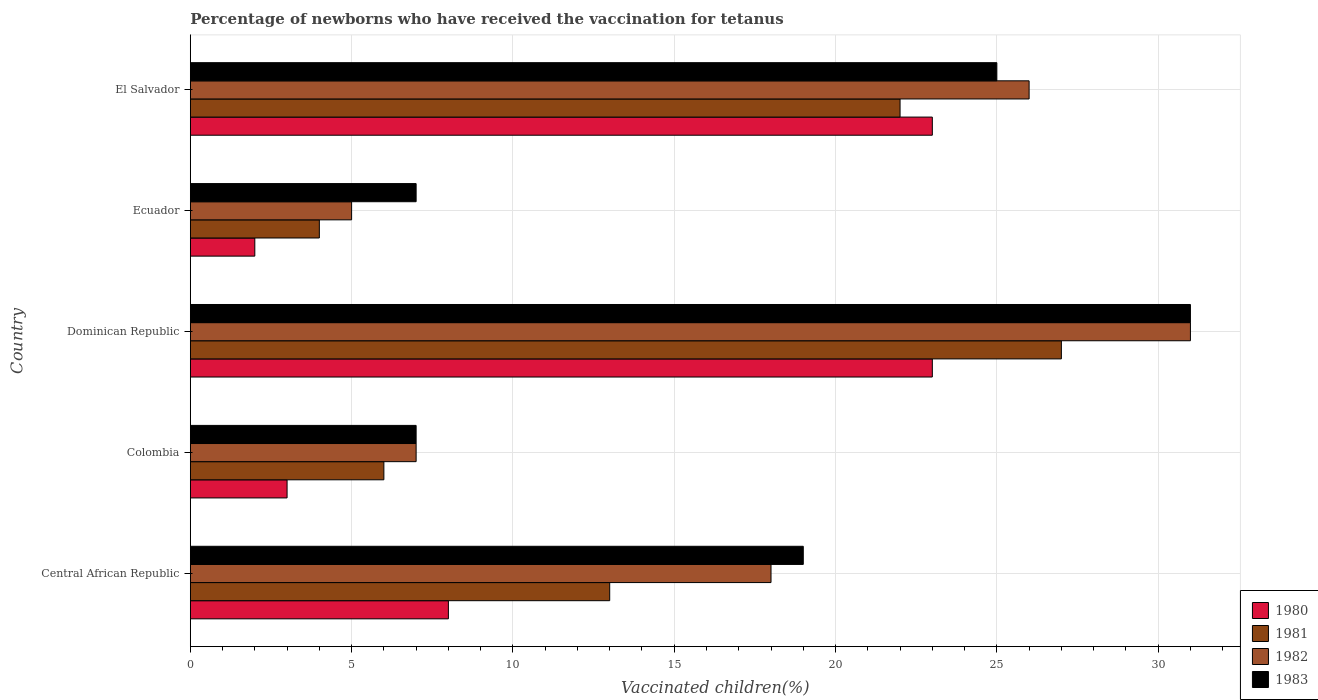How many groups of bars are there?
Ensure brevity in your answer.  5. How many bars are there on the 4th tick from the top?
Keep it short and to the point. 4. How many bars are there on the 1st tick from the bottom?
Ensure brevity in your answer.  4. What is the label of the 2nd group of bars from the top?
Your response must be concise. Ecuador. In which country was the percentage of vaccinated children in 1983 maximum?
Your answer should be very brief. Dominican Republic. In which country was the percentage of vaccinated children in 1980 minimum?
Give a very brief answer. Ecuador. What is the total percentage of vaccinated children in 1983 in the graph?
Your response must be concise. 89. What is the difference between the percentage of vaccinated children in 1982 and percentage of vaccinated children in 1983 in Colombia?
Give a very brief answer. 0. What is the ratio of the percentage of vaccinated children in 1980 in Central African Republic to that in Colombia?
Your answer should be compact. 2.67. Is the percentage of vaccinated children in 1983 in Central African Republic less than that in Colombia?
Offer a very short reply. No. Is the difference between the percentage of vaccinated children in 1982 in Colombia and Ecuador greater than the difference between the percentage of vaccinated children in 1983 in Colombia and Ecuador?
Give a very brief answer. Yes. What is the difference between the highest and the lowest percentage of vaccinated children in 1981?
Keep it short and to the point. 23. In how many countries, is the percentage of vaccinated children in 1982 greater than the average percentage of vaccinated children in 1982 taken over all countries?
Your response must be concise. 3. Is the sum of the percentage of vaccinated children in 1980 in Central African Republic and Colombia greater than the maximum percentage of vaccinated children in 1982 across all countries?
Ensure brevity in your answer.  No. Is it the case that in every country, the sum of the percentage of vaccinated children in 1983 and percentage of vaccinated children in 1982 is greater than the sum of percentage of vaccinated children in 1981 and percentage of vaccinated children in 1980?
Your answer should be compact. No. Is it the case that in every country, the sum of the percentage of vaccinated children in 1983 and percentage of vaccinated children in 1982 is greater than the percentage of vaccinated children in 1980?
Ensure brevity in your answer.  Yes. How many bars are there?
Keep it short and to the point. 20. What is the difference between two consecutive major ticks on the X-axis?
Provide a short and direct response. 5. Does the graph contain any zero values?
Ensure brevity in your answer.  No. What is the title of the graph?
Your answer should be compact. Percentage of newborns who have received the vaccination for tetanus. What is the label or title of the X-axis?
Your answer should be compact. Vaccinated children(%). What is the label or title of the Y-axis?
Your answer should be very brief. Country. What is the Vaccinated children(%) in 1981 in Central African Republic?
Your answer should be compact. 13. What is the Vaccinated children(%) of 1983 in Central African Republic?
Your answer should be compact. 19. What is the Vaccinated children(%) of 1983 in Colombia?
Provide a succinct answer. 7. What is the Vaccinated children(%) in 1980 in Dominican Republic?
Make the answer very short. 23. What is the Vaccinated children(%) in 1981 in Dominican Republic?
Your answer should be very brief. 27. What is the Vaccinated children(%) of 1982 in Dominican Republic?
Give a very brief answer. 31. What is the Vaccinated children(%) of 1983 in Dominican Republic?
Keep it short and to the point. 31. What is the Vaccinated children(%) of 1980 in Ecuador?
Your answer should be very brief. 2. What is the Vaccinated children(%) of 1983 in Ecuador?
Provide a short and direct response. 7. What is the Vaccinated children(%) of 1980 in El Salvador?
Give a very brief answer. 23. What is the Vaccinated children(%) of 1981 in El Salvador?
Offer a very short reply. 22. Across all countries, what is the maximum Vaccinated children(%) of 1980?
Keep it short and to the point. 23. Across all countries, what is the maximum Vaccinated children(%) in 1982?
Your response must be concise. 31. Across all countries, what is the maximum Vaccinated children(%) of 1983?
Give a very brief answer. 31. Across all countries, what is the minimum Vaccinated children(%) of 1980?
Offer a terse response. 2. Across all countries, what is the minimum Vaccinated children(%) of 1981?
Ensure brevity in your answer.  4. Across all countries, what is the minimum Vaccinated children(%) of 1982?
Provide a short and direct response. 5. Across all countries, what is the minimum Vaccinated children(%) in 1983?
Your answer should be very brief. 7. What is the total Vaccinated children(%) of 1983 in the graph?
Offer a very short reply. 89. What is the difference between the Vaccinated children(%) in 1982 in Central African Republic and that in Colombia?
Offer a terse response. 11. What is the difference between the Vaccinated children(%) in 1980 in Central African Republic and that in Dominican Republic?
Provide a short and direct response. -15. What is the difference between the Vaccinated children(%) of 1982 in Central African Republic and that in Dominican Republic?
Provide a succinct answer. -13. What is the difference between the Vaccinated children(%) of 1980 in Central African Republic and that in Ecuador?
Offer a terse response. 6. What is the difference between the Vaccinated children(%) of 1981 in Central African Republic and that in Ecuador?
Provide a succinct answer. 9. What is the difference between the Vaccinated children(%) in 1983 in Central African Republic and that in Ecuador?
Keep it short and to the point. 12. What is the difference between the Vaccinated children(%) in 1980 in Central African Republic and that in El Salvador?
Provide a succinct answer. -15. What is the difference between the Vaccinated children(%) in 1981 in Central African Republic and that in El Salvador?
Your answer should be compact. -9. What is the difference between the Vaccinated children(%) of 1980 in Colombia and that in Dominican Republic?
Your answer should be compact. -20. What is the difference between the Vaccinated children(%) of 1981 in Colombia and that in Dominican Republic?
Give a very brief answer. -21. What is the difference between the Vaccinated children(%) of 1982 in Colombia and that in Dominican Republic?
Provide a succinct answer. -24. What is the difference between the Vaccinated children(%) in 1983 in Colombia and that in Dominican Republic?
Keep it short and to the point. -24. What is the difference between the Vaccinated children(%) in 1981 in Colombia and that in El Salvador?
Provide a succinct answer. -16. What is the difference between the Vaccinated children(%) in 1983 in Colombia and that in El Salvador?
Make the answer very short. -18. What is the difference between the Vaccinated children(%) of 1980 in Dominican Republic and that in Ecuador?
Give a very brief answer. 21. What is the difference between the Vaccinated children(%) of 1982 in Dominican Republic and that in Ecuador?
Your answer should be very brief. 26. What is the difference between the Vaccinated children(%) of 1981 in Dominican Republic and that in El Salvador?
Ensure brevity in your answer.  5. What is the difference between the Vaccinated children(%) of 1983 in Dominican Republic and that in El Salvador?
Provide a succinct answer. 6. What is the difference between the Vaccinated children(%) in 1980 in Ecuador and that in El Salvador?
Your answer should be compact. -21. What is the difference between the Vaccinated children(%) in 1981 in Ecuador and that in El Salvador?
Offer a terse response. -18. What is the difference between the Vaccinated children(%) of 1982 in Ecuador and that in El Salvador?
Your answer should be very brief. -21. What is the difference between the Vaccinated children(%) of 1983 in Ecuador and that in El Salvador?
Your answer should be compact. -18. What is the difference between the Vaccinated children(%) in 1981 in Central African Republic and the Vaccinated children(%) in 1982 in Colombia?
Make the answer very short. 6. What is the difference between the Vaccinated children(%) in 1981 in Central African Republic and the Vaccinated children(%) in 1983 in Colombia?
Provide a short and direct response. 6. What is the difference between the Vaccinated children(%) of 1982 in Central African Republic and the Vaccinated children(%) of 1983 in Colombia?
Give a very brief answer. 11. What is the difference between the Vaccinated children(%) of 1980 in Central African Republic and the Vaccinated children(%) of 1983 in Dominican Republic?
Your response must be concise. -23. What is the difference between the Vaccinated children(%) in 1981 in Central African Republic and the Vaccinated children(%) in 1982 in Dominican Republic?
Keep it short and to the point. -18. What is the difference between the Vaccinated children(%) of 1981 in Central African Republic and the Vaccinated children(%) of 1983 in Dominican Republic?
Make the answer very short. -18. What is the difference between the Vaccinated children(%) in 1982 in Central African Republic and the Vaccinated children(%) in 1983 in Dominican Republic?
Offer a terse response. -13. What is the difference between the Vaccinated children(%) of 1980 in Central African Republic and the Vaccinated children(%) of 1981 in Ecuador?
Offer a very short reply. 4. What is the difference between the Vaccinated children(%) of 1980 in Central African Republic and the Vaccinated children(%) of 1982 in Ecuador?
Your answer should be compact. 3. What is the difference between the Vaccinated children(%) of 1980 in Central African Republic and the Vaccinated children(%) of 1983 in Ecuador?
Make the answer very short. 1. What is the difference between the Vaccinated children(%) of 1981 in Central African Republic and the Vaccinated children(%) of 1982 in Ecuador?
Keep it short and to the point. 8. What is the difference between the Vaccinated children(%) in 1981 in Central African Republic and the Vaccinated children(%) in 1983 in Ecuador?
Offer a very short reply. 6. What is the difference between the Vaccinated children(%) of 1980 in Central African Republic and the Vaccinated children(%) of 1982 in El Salvador?
Offer a very short reply. -18. What is the difference between the Vaccinated children(%) of 1981 in Central African Republic and the Vaccinated children(%) of 1982 in El Salvador?
Your response must be concise. -13. What is the difference between the Vaccinated children(%) of 1981 in Central African Republic and the Vaccinated children(%) of 1983 in El Salvador?
Ensure brevity in your answer.  -12. What is the difference between the Vaccinated children(%) of 1982 in Central African Republic and the Vaccinated children(%) of 1983 in El Salvador?
Your answer should be compact. -7. What is the difference between the Vaccinated children(%) in 1980 in Colombia and the Vaccinated children(%) in 1981 in Dominican Republic?
Offer a terse response. -24. What is the difference between the Vaccinated children(%) in 1980 in Colombia and the Vaccinated children(%) in 1982 in Dominican Republic?
Your answer should be compact. -28. What is the difference between the Vaccinated children(%) of 1980 in Colombia and the Vaccinated children(%) of 1983 in Dominican Republic?
Keep it short and to the point. -28. What is the difference between the Vaccinated children(%) of 1981 in Colombia and the Vaccinated children(%) of 1982 in Dominican Republic?
Your answer should be very brief. -25. What is the difference between the Vaccinated children(%) of 1981 in Colombia and the Vaccinated children(%) of 1983 in Dominican Republic?
Ensure brevity in your answer.  -25. What is the difference between the Vaccinated children(%) in 1982 in Colombia and the Vaccinated children(%) in 1983 in Dominican Republic?
Your answer should be very brief. -24. What is the difference between the Vaccinated children(%) of 1981 in Colombia and the Vaccinated children(%) of 1982 in Ecuador?
Your answer should be compact. 1. What is the difference between the Vaccinated children(%) in 1982 in Colombia and the Vaccinated children(%) in 1983 in Ecuador?
Give a very brief answer. 0. What is the difference between the Vaccinated children(%) in 1980 in Colombia and the Vaccinated children(%) in 1981 in El Salvador?
Offer a very short reply. -19. What is the difference between the Vaccinated children(%) of 1980 in Colombia and the Vaccinated children(%) of 1982 in El Salvador?
Ensure brevity in your answer.  -23. What is the difference between the Vaccinated children(%) in 1981 in Colombia and the Vaccinated children(%) in 1982 in El Salvador?
Give a very brief answer. -20. What is the difference between the Vaccinated children(%) of 1981 in Colombia and the Vaccinated children(%) of 1983 in El Salvador?
Your answer should be compact. -19. What is the difference between the Vaccinated children(%) in 1980 in Dominican Republic and the Vaccinated children(%) in 1983 in Ecuador?
Make the answer very short. 16. What is the difference between the Vaccinated children(%) in 1982 in Dominican Republic and the Vaccinated children(%) in 1983 in Ecuador?
Ensure brevity in your answer.  24. What is the difference between the Vaccinated children(%) in 1980 in Dominican Republic and the Vaccinated children(%) in 1981 in El Salvador?
Keep it short and to the point. 1. What is the difference between the Vaccinated children(%) of 1981 in Dominican Republic and the Vaccinated children(%) of 1982 in El Salvador?
Keep it short and to the point. 1. What is the difference between the Vaccinated children(%) in 1981 in Dominican Republic and the Vaccinated children(%) in 1983 in El Salvador?
Keep it short and to the point. 2. What is the difference between the Vaccinated children(%) in 1980 in Ecuador and the Vaccinated children(%) in 1981 in El Salvador?
Keep it short and to the point. -20. What is the difference between the Vaccinated children(%) in 1980 in Ecuador and the Vaccinated children(%) in 1982 in El Salvador?
Offer a very short reply. -24. What is the difference between the Vaccinated children(%) in 1981 in Ecuador and the Vaccinated children(%) in 1982 in El Salvador?
Give a very brief answer. -22. What is the average Vaccinated children(%) of 1980 per country?
Your response must be concise. 11.8. What is the average Vaccinated children(%) in 1981 per country?
Offer a terse response. 14.4. What is the average Vaccinated children(%) in 1982 per country?
Offer a very short reply. 17.4. What is the average Vaccinated children(%) in 1983 per country?
Provide a short and direct response. 17.8. What is the difference between the Vaccinated children(%) of 1980 and Vaccinated children(%) of 1981 in Central African Republic?
Provide a succinct answer. -5. What is the difference between the Vaccinated children(%) of 1981 and Vaccinated children(%) of 1982 in Central African Republic?
Provide a short and direct response. -5. What is the difference between the Vaccinated children(%) of 1982 and Vaccinated children(%) of 1983 in Central African Republic?
Your answer should be compact. -1. What is the difference between the Vaccinated children(%) of 1980 and Vaccinated children(%) of 1982 in Colombia?
Offer a very short reply. -4. What is the difference between the Vaccinated children(%) in 1981 and Vaccinated children(%) in 1982 in Colombia?
Offer a very short reply. -1. What is the difference between the Vaccinated children(%) of 1981 and Vaccinated children(%) of 1983 in Colombia?
Your answer should be compact. -1. What is the difference between the Vaccinated children(%) of 1980 and Vaccinated children(%) of 1981 in Dominican Republic?
Your response must be concise. -4. What is the difference between the Vaccinated children(%) of 1980 and Vaccinated children(%) of 1983 in Dominican Republic?
Provide a succinct answer. -8. What is the difference between the Vaccinated children(%) in 1981 and Vaccinated children(%) in 1982 in Dominican Republic?
Offer a terse response. -4. What is the difference between the Vaccinated children(%) in 1981 and Vaccinated children(%) in 1983 in Dominican Republic?
Your answer should be compact. -4. What is the difference between the Vaccinated children(%) of 1982 and Vaccinated children(%) of 1983 in Dominican Republic?
Provide a succinct answer. 0. What is the difference between the Vaccinated children(%) of 1980 and Vaccinated children(%) of 1982 in Ecuador?
Make the answer very short. -3. What is the difference between the Vaccinated children(%) of 1980 and Vaccinated children(%) of 1983 in Ecuador?
Provide a succinct answer. -5. What is the difference between the Vaccinated children(%) in 1981 and Vaccinated children(%) in 1982 in Ecuador?
Your response must be concise. -1. What is the difference between the Vaccinated children(%) of 1982 and Vaccinated children(%) of 1983 in Ecuador?
Your response must be concise. -2. What is the difference between the Vaccinated children(%) of 1980 and Vaccinated children(%) of 1981 in El Salvador?
Ensure brevity in your answer.  1. What is the difference between the Vaccinated children(%) of 1982 and Vaccinated children(%) of 1983 in El Salvador?
Your answer should be very brief. 1. What is the ratio of the Vaccinated children(%) of 1980 in Central African Republic to that in Colombia?
Your answer should be compact. 2.67. What is the ratio of the Vaccinated children(%) of 1981 in Central African Republic to that in Colombia?
Your answer should be compact. 2.17. What is the ratio of the Vaccinated children(%) in 1982 in Central African Republic to that in Colombia?
Offer a very short reply. 2.57. What is the ratio of the Vaccinated children(%) in 1983 in Central African Republic to that in Colombia?
Your answer should be compact. 2.71. What is the ratio of the Vaccinated children(%) in 1980 in Central African Republic to that in Dominican Republic?
Keep it short and to the point. 0.35. What is the ratio of the Vaccinated children(%) in 1981 in Central African Republic to that in Dominican Republic?
Your response must be concise. 0.48. What is the ratio of the Vaccinated children(%) of 1982 in Central African Republic to that in Dominican Republic?
Provide a short and direct response. 0.58. What is the ratio of the Vaccinated children(%) of 1983 in Central African Republic to that in Dominican Republic?
Your answer should be very brief. 0.61. What is the ratio of the Vaccinated children(%) of 1980 in Central African Republic to that in Ecuador?
Provide a succinct answer. 4. What is the ratio of the Vaccinated children(%) in 1981 in Central African Republic to that in Ecuador?
Provide a short and direct response. 3.25. What is the ratio of the Vaccinated children(%) of 1982 in Central African Republic to that in Ecuador?
Your answer should be compact. 3.6. What is the ratio of the Vaccinated children(%) in 1983 in Central African Republic to that in Ecuador?
Give a very brief answer. 2.71. What is the ratio of the Vaccinated children(%) in 1980 in Central African Republic to that in El Salvador?
Keep it short and to the point. 0.35. What is the ratio of the Vaccinated children(%) of 1981 in Central African Republic to that in El Salvador?
Offer a terse response. 0.59. What is the ratio of the Vaccinated children(%) in 1982 in Central African Republic to that in El Salvador?
Offer a terse response. 0.69. What is the ratio of the Vaccinated children(%) of 1983 in Central African Republic to that in El Salvador?
Ensure brevity in your answer.  0.76. What is the ratio of the Vaccinated children(%) in 1980 in Colombia to that in Dominican Republic?
Offer a terse response. 0.13. What is the ratio of the Vaccinated children(%) in 1981 in Colombia to that in Dominican Republic?
Your answer should be very brief. 0.22. What is the ratio of the Vaccinated children(%) in 1982 in Colombia to that in Dominican Republic?
Offer a terse response. 0.23. What is the ratio of the Vaccinated children(%) of 1983 in Colombia to that in Dominican Republic?
Make the answer very short. 0.23. What is the ratio of the Vaccinated children(%) in 1980 in Colombia to that in Ecuador?
Your answer should be compact. 1.5. What is the ratio of the Vaccinated children(%) of 1983 in Colombia to that in Ecuador?
Make the answer very short. 1. What is the ratio of the Vaccinated children(%) of 1980 in Colombia to that in El Salvador?
Provide a succinct answer. 0.13. What is the ratio of the Vaccinated children(%) in 1981 in Colombia to that in El Salvador?
Keep it short and to the point. 0.27. What is the ratio of the Vaccinated children(%) in 1982 in Colombia to that in El Salvador?
Give a very brief answer. 0.27. What is the ratio of the Vaccinated children(%) of 1983 in Colombia to that in El Salvador?
Your answer should be very brief. 0.28. What is the ratio of the Vaccinated children(%) of 1981 in Dominican Republic to that in Ecuador?
Make the answer very short. 6.75. What is the ratio of the Vaccinated children(%) in 1982 in Dominican Republic to that in Ecuador?
Ensure brevity in your answer.  6.2. What is the ratio of the Vaccinated children(%) in 1983 in Dominican Republic to that in Ecuador?
Offer a terse response. 4.43. What is the ratio of the Vaccinated children(%) in 1981 in Dominican Republic to that in El Salvador?
Your answer should be very brief. 1.23. What is the ratio of the Vaccinated children(%) in 1982 in Dominican Republic to that in El Salvador?
Provide a succinct answer. 1.19. What is the ratio of the Vaccinated children(%) in 1983 in Dominican Republic to that in El Salvador?
Provide a succinct answer. 1.24. What is the ratio of the Vaccinated children(%) of 1980 in Ecuador to that in El Salvador?
Your answer should be compact. 0.09. What is the ratio of the Vaccinated children(%) of 1981 in Ecuador to that in El Salvador?
Keep it short and to the point. 0.18. What is the ratio of the Vaccinated children(%) in 1982 in Ecuador to that in El Salvador?
Provide a succinct answer. 0.19. What is the ratio of the Vaccinated children(%) in 1983 in Ecuador to that in El Salvador?
Your response must be concise. 0.28. What is the difference between the highest and the second highest Vaccinated children(%) in 1980?
Offer a terse response. 0. What is the difference between the highest and the second highest Vaccinated children(%) in 1981?
Provide a succinct answer. 5. What is the difference between the highest and the lowest Vaccinated children(%) of 1980?
Offer a very short reply. 21. What is the difference between the highest and the lowest Vaccinated children(%) of 1982?
Provide a short and direct response. 26. What is the difference between the highest and the lowest Vaccinated children(%) in 1983?
Provide a succinct answer. 24. 